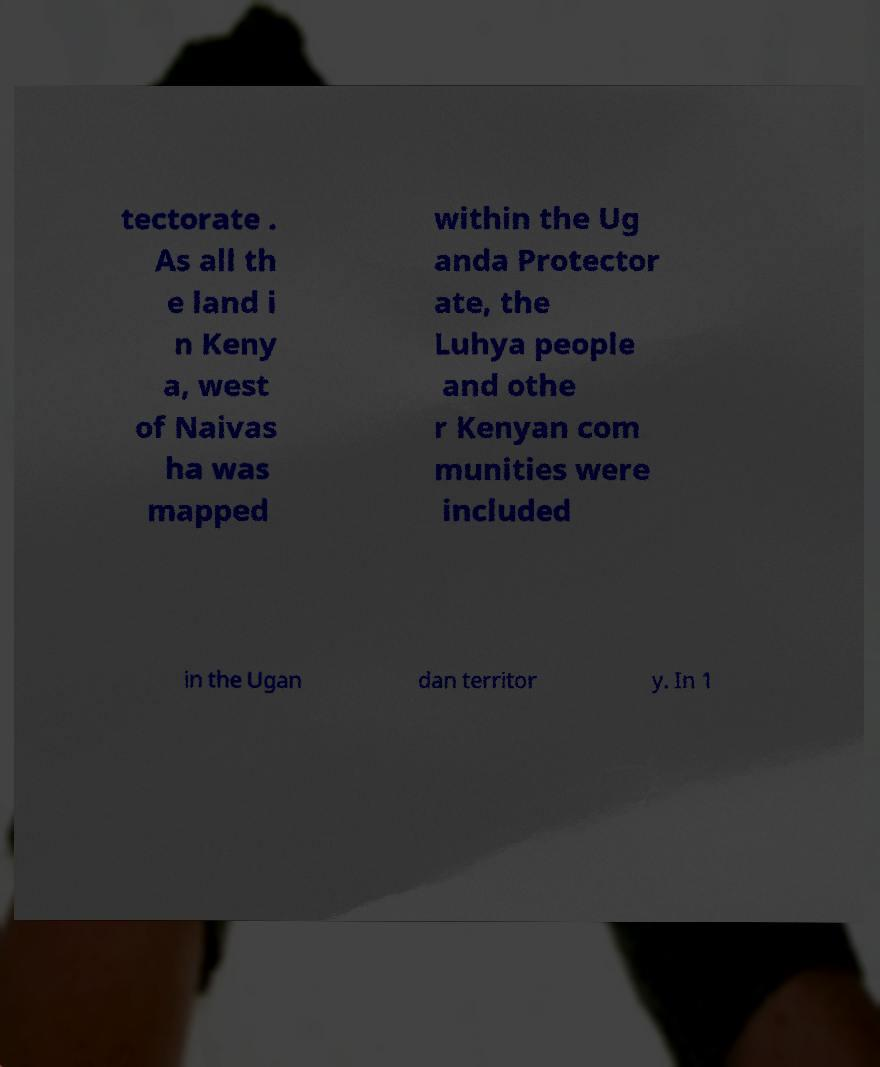Please read and relay the text visible in this image. What does it say? tectorate . As all th e land i n Keny a, west of Naivas ha was mapped within the Ug anda Protector ate, the Luhya people and othe r Kenyan com munities were included in the Ugan dan territor y. In 1 